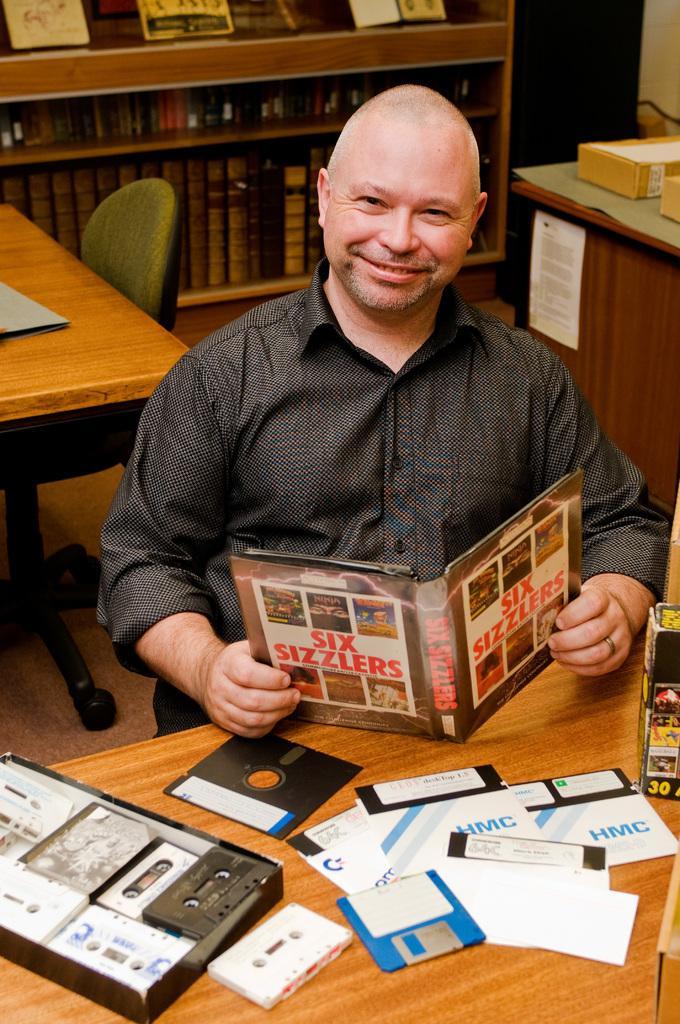Please provide a concise description of this image. In this image there is a man wearing a black shirt holding a book. He is smiling. In front of him there is a table. On the table there are few books,cassettes,cds. Behind the man there is another table and chair,there is a book rack. 